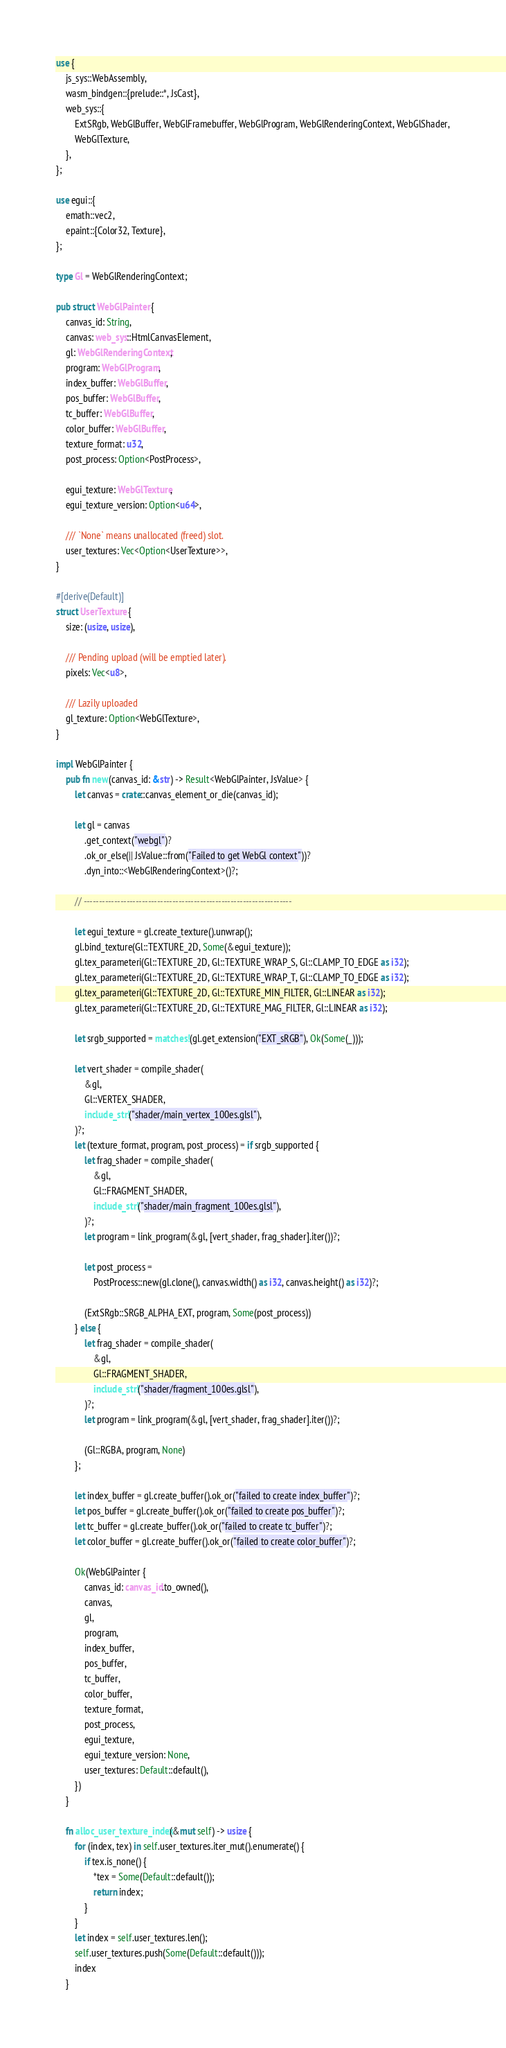Convert code to text. <code><loc_0><loc_0><loc_500><loc_500><_Rust_>use {
    js_sys::WebAssembly,
    wasm_bindgen::{prelude::*, JsCast},
    web_sys::{
        ExtSRgb, WebGlBuffer, WebGlFramebuffer, WebGlProgram, WebGlRenderingContext, WebGlShader,
        WebGlTexture,
    },
};

use egui::{
    emath::vec2,
    epaint::{Color32, Texture},
};

type Gl = WebGlRenderingContext;

pub struct WebGlPainter {
    canvas_id: String,
    canvas: web_sys::HtmlCanvasElement,
    gl: WebGlRenderingContext,
    program: WebGlProgram,
    index_buffer: WebGlBuffer,
    pos_buffer: WebGlBuffer,
    tc_buffer: WebGlBuffer,
    color_buffer: WebGlBuffer,
    texture_format: u32,
    post_process: Option<PostProcess>,

    egui_texture: WebGlTexture,
    egui_texture_version: Option<u64>,

    /// `None` means unallocated (freed) slot.
    user_textures: Vec<Option<UserTexture>>,
}

#[derive(Default)]
struct UserTexture {
    size: (usize, usize),

    /// Pending upload (will be emptied later).
    pixels: Vec<u8>,

    /// Lazily uploaded
    gl_texture: Option<WebGlTexture>,
}

impl WebGlPainter {
    pub fn new(canvas_id: &str) -> Result<WebGlPainter, JsValue> {
        let canvas = crate::canvas_element_or_die(canvas_id);

        let gl = canvas
            .get_context("webgl")?
            .ok_or_else(|| JsValue::from("Failed to get WebGl context"))?
            .dyn_into::<WebGlRenderingContext>()?;

        // --------------------------------------------------------------------

        let egui_texture = gl.create_texture().unwrap();
        gl.bind_texture(Gl::TEXTURE_2D, Some(&egui_texture));
        gl.tex_parameteri(Gl::TEXTURE_2D, Gl::TEXTURE_WRAP_S, Gl::CLAMP_TO_EDGE as i32);
        gl.tex_parameteri(Gl::TEXTURE_2D, Gl::TEXTURE_WRAP_T, Gl::CLAMP_TO_EDGE as i32);
        gl.tex_parameteri(Gl::TEXTURE_2D, Gl::TEXTURE_MIN_FILTER, Gl::LINEAR as i32);
        gl.tex_parameteri(Gl::TEXTURE_2D, Gl::TEXTURE_MAG_FILTER, Gl::LINEAR as i32);

        let srgb_supported = matches!(gl.get_extension("EXT_sRGB"), Ok(Some(_)));

        let vert_shader = compile_shader(
            &gl,
            Gl::VERTEX_SHADER,
            include_str!("shader/main_vertex_100es.glsl"),
        )?;
        let (texture_format, program, post_process) = if srgb_supported {
            let frag_shader = compile_shader(
                &gl,
                Gl::FRAGMENT_SHADER,
                include_str!("shader/main_fragment_100es.glsl"),
            )?;
            let program = link_program(&gl, [vert_shader, frag_shader].iter())?;

            let post_process =
                PostProcess::new(gl.clone(), canvas.width() as i32, canvas.height() as i32)?;

            (ExtSRgb::SRGB_ALPHA_EXT, program, Some(post_process))
        } else {
            let frag_shader = compile_shader(
                &gl,
                Gl::FRAGMENT_SHADER,
                include_str!("shader/fragment_100es.glsl"),
            )?;
            let program = link_program(&gl, [vert_shader, frag_shader].iter())?;

            (Gl::RGBA, program, None)
        };

        let index_buffer = gl.create_buffer().ok_or("failed to create index_buffer")?;
        let pos_buffer = gl.create_buffer().ok_or("failed to create pos_buffer")?;
        let tc_buffer = gl.create_buffer().ok_or("failed to create tc_buffer")?;
        let color_buffer = gl.create_buffer().ok_or("failed to create color_buffer")?;

        Ok(WebGlPainter {
            canvas_id: canvas_id.to_owned(),
            canvas,
            gl,
            program,
            index_buffer,
            pos_buffer,
            tc_buffer,
            color_buffer,
            texture_format,
            post_process,
            egui_texture,
            egui_texture_version: None,
            user_textures: Default::default(),
        })
    }

    fn alloc_user_texture_index(&mut self) -> usize {
        for (index, tex) in self.user_textures.iter_mut().enumerate() {
            if tex.is_none() {
                *tex = Some(Default::default());
                return index;
            }
        }
        let index = self.user_textures.len();
        self.user_textures.push(Some(Default::default()));
        index
    }
</code> 